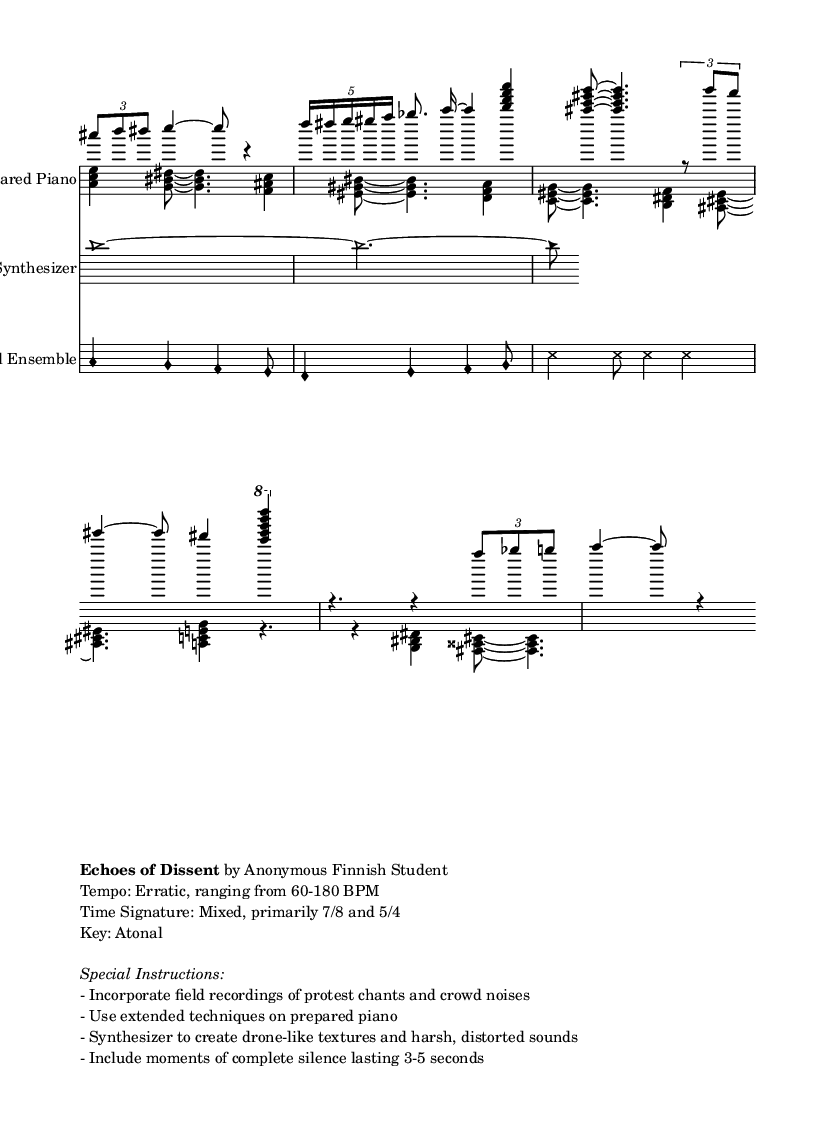What is the time signature of this music? The time signature is primarily 7/8, indicated in the global section of the code. It is a mixed time signature, but 7/8 is the predominant one highlighted.
Answer: 7/8 What is the tempo of this music? The tempo is described as erratic, ranging from 60 to 180 BPM as stated in the markup instructions. This indicates a varied tempo rather than a fixed one.
Answer: Erratic, 60-180 BPM What is the key of this composition? The key of this composition is atonal, as specified in the markup section. Atonal music does not conform to traditional major or minor key signatures.
Answer: Atonal What type of textures are created by the synthesizer? The synthesizer is instructed to create drone-like textures and harsh, distorted sounds, as noted in the special instructions. This defines the unique sound character produced by this instrument.
Answer: Drone-like textures, harsh sounds How many voices are used in the piano staff? There are two voices used in the piano staff, as indicated by the lines that state Voice One and Voice Two for the right and left piano parts, respectively.
Answer: Two What extended techniques are suggested for the prepared piano? The special instructions specify incorporating extended techniques on the prepared piano, which refers to unconventional playing methods like preparations added to the piano strings.
Answer: Extended techniques What type of melody is inspired by Gregorian chant? The vocals section contains a melody that is inspired by Gregorian chant, indicated by the specific style of noteheads used and the melodic contour that resembles chant melodies.
Answer: Gregorian chant-inspired melody 